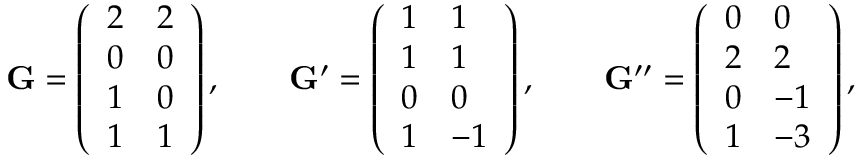<formula> <loc_0><loc_0><loc_500><loc_500>\mathbf G = \left ( \begin{array} { l l } { 2 } & { 2 } \\ { 0 } & { 0 } \\ { 1 } & { 0 } \\ { 1 } & { 1 } \end{array} \right ) , \quad \mathbf G ^ { \prime } = \left ( \begin{array} { l l } { 1 } & { 1 } \\ { 1 } & { 1 } \\ { 0 } & { 0 } \\ { 1 } & { - 1 } \end{array} \right ) , \quad \mathbf G ^ { \prime \prime } = \left ( \begin{array} { l l } { 0 } & { 0 } \\ { 2 } & { 2 } \\ { 0 } & { - 1 } \\ { 1 } & { - 3 } \end{array} \right ) ,</formula> 